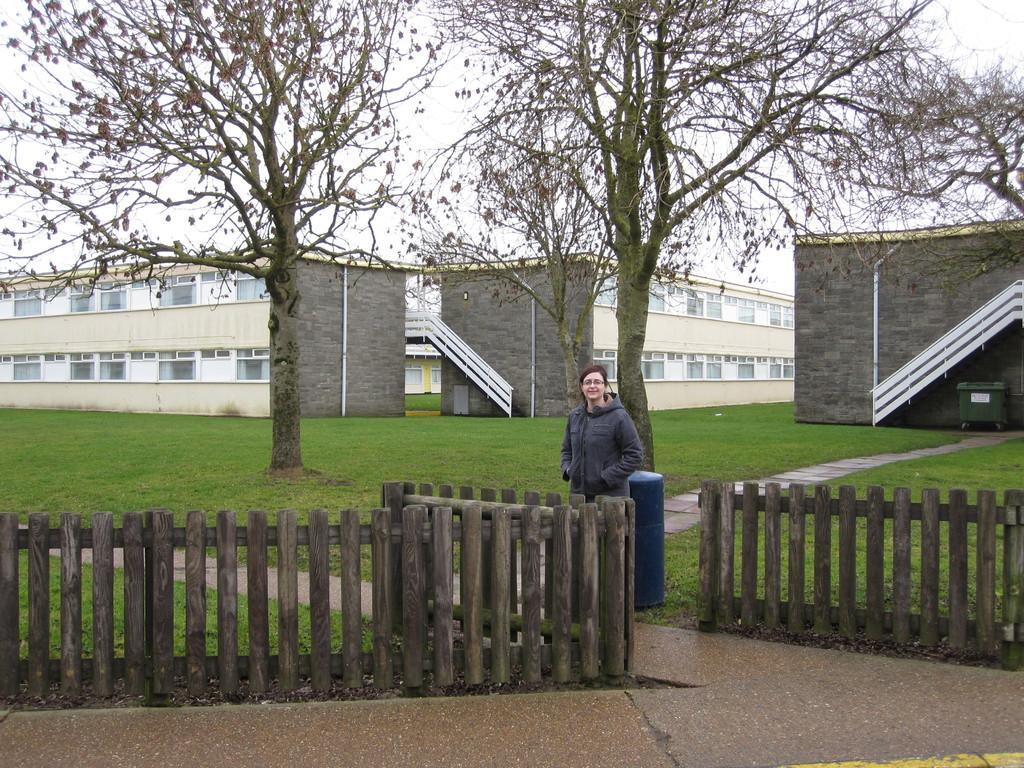In one or two sentences, can you explain what this image depicts? In this image I can see the ground, the wooden fencing ,a person standing, a blue colored object on the ground, few trees and few buildings which are cream and black in color. I can see a bin to the right side of the image and In the background I can see the sky. 